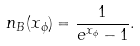Convert formula to latex. <formula><loc_0><loc_0><loc_500><loc_500>n _ { B } ( x _ { \phi } ) = \frac { 1 } { e ^ { x _ { \phi } } - 1 } .</formula> 